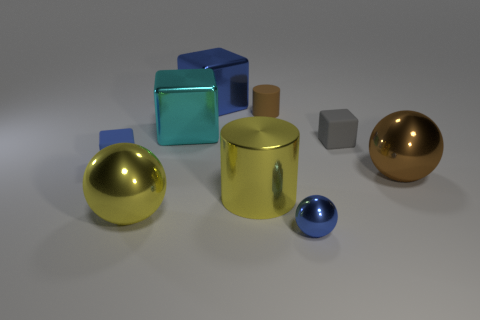Based on the arrangement of objects, what can you infer about the purpose of the composition? The deliberate placement of objects with varying shapes, sizes, and colors seems to be an intentional composition designed to exhibit contrasts and the interplay of light on different surfaces. It may be an artistic arrangement meant to showcase the principles of geometry and reflectivity. 